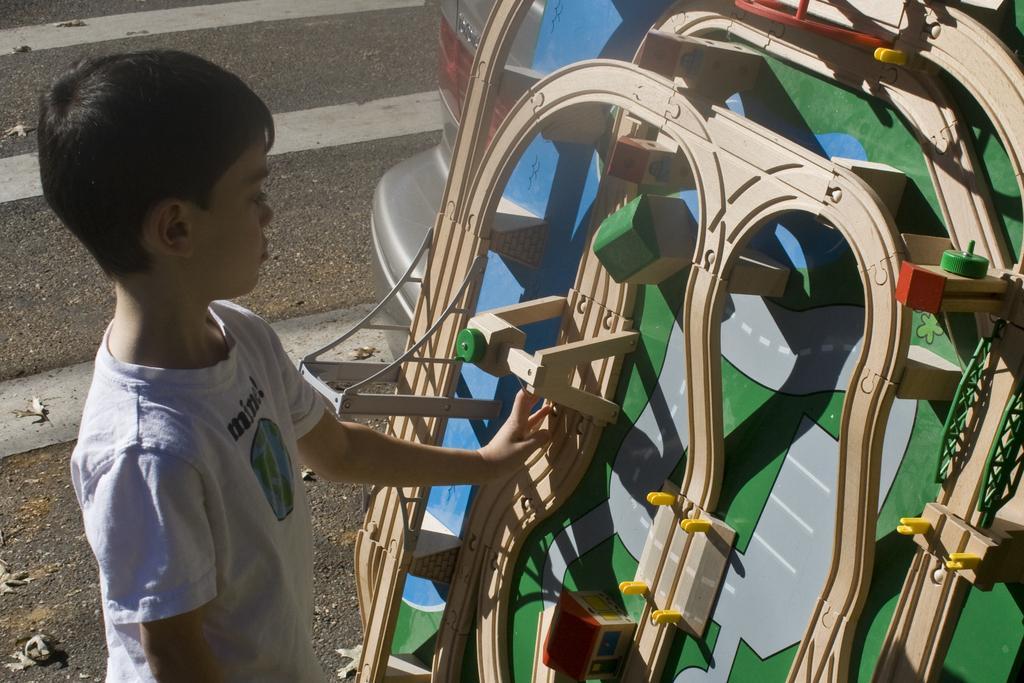In one or two sentences, can you explain what this image depicts? There is a kid wearing white dress is standing and there is an object in front of him. 